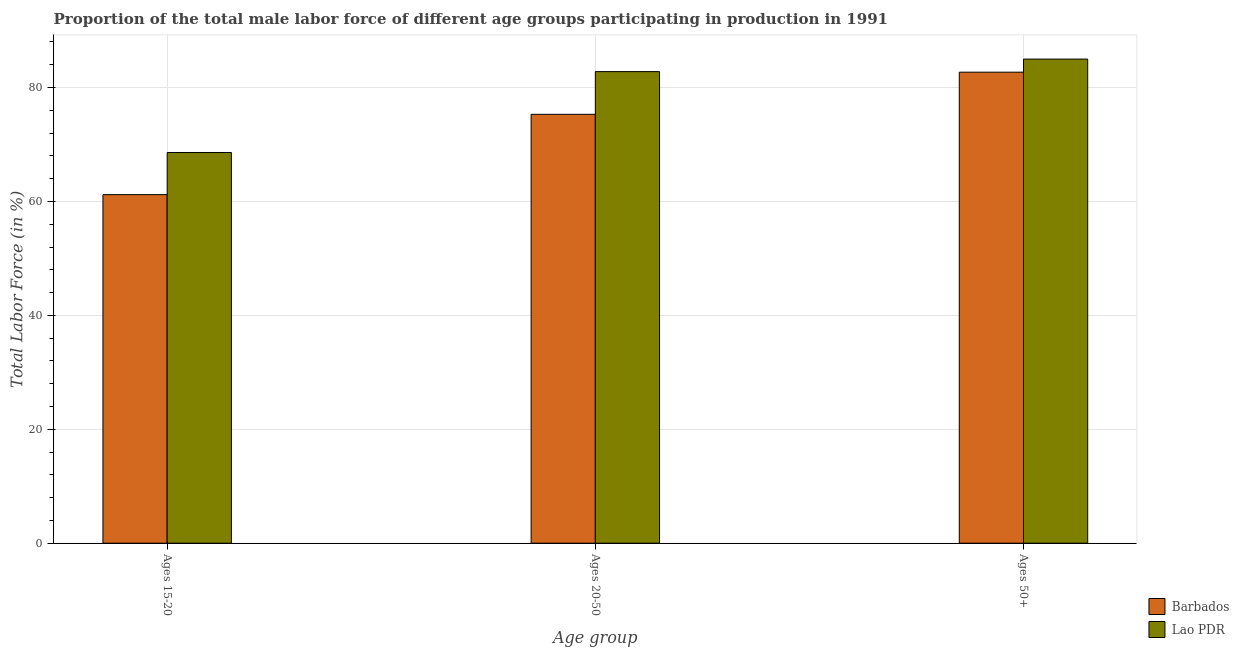How many groups of bars are there?
Your answer should be compact. 3. Are the number of bars on each tick of the X-axis equal?
Offer a very short reply. Yes. How many bars are there on the 2nd tick from the left?
Offer a terse response. 2. How many bars are there on the 3rd tick from the right?
Keep it short and to the point. 2. What is the label of the 2nd group of bars from the left?
Offer a very short reply. Ages 20-50. What is the percentage of male labor force above age 50 in Barbados?
Your answer should be compact. 82.7. Across all countries, what is the minimum percentage of male labor force within the age group 20-50?
Your answer should be very brief. 75.3. In which country was the percentage of male labor force within the age group 20-50 maximum?
Your answer should be very brief. Lao PDR. In which country was the percentage of male labor force above age 50 minimum?
Your response must be concise. Barbados. What is the total percentage of male labor force above age 50 in the graph?
Your response must be concise. 167.7. What is the difference between the percentage of male labor force within the age group 20-50 in Barbados and that in Lao PDR?
Your response must be concise. -7.5. What is the difference between the percentage of male labor force within the age group 20-50 in Lao PDR and the percentage of male labor force above age 50 in Barbados?
Make the answer very short. 0.1. What is the average percentage of male labor force within the age group 20-50 per country?
Offer a very short reply. 79.05. What is the difference between the percentage of male labor force above age 50 and percentage of male labor force within the age group 15-20 in Barbados?
Your answer should be very brief. 21.5. What is the ratio of the percentage of male labor force within the age group 20-50 in Lao PDR to that in Barbados?
Ensure brevity in your answer.  1.1. Is the percentage of male labor force within the age group 20-50 in Lao PDR less than that in Barbados?
Offer a terse response. No. What is the difference between the highest and the second highest percentage of male labor force within the age group 15-20?
Offer a very short reply. 7.4. What does the 2nd bar from the left in Ages 50+ represents?
Provide a succinct answer. Lao PDR. What does the 1st bar from the right in Ages 15-20 represents?
Provide a short and direct response. Lao PDR. How many bars are there?
Keep it short and to the point. 6. How many countries are there in the graph?
Your response must be concise. 2. Does the graph contain any zero values?
Your answer should be very brief. No. How many legend labels are there?
Offer a terse response. 2. What is the title of the graph?
Your answer should be very brief. Proportion of the total male labor force of different age groups participating in production in 1991. What is the label or title of the X-axis?
Keep it short and to the point. Age group. What is the label or title of the Y-axis?
Offer a terse response. Total Labor Force (in %). What is the Total Labor Force (in %) of Barbados in Ages 15-20?
Your answer should be very brief. 61.2. What is the Total Labor Force (in %) in Lao PDR in Ages 15-20?
Offer a very short reply. 68.6. What is the Total Labor Force (in %) of Barbados in Ages 20-50?
Make the answer very short. 75.3. What is the Total Labor Force (in %) in Lao PDR in Ages 20-50?
Give a very brief answer. 82.8. What is the Total Labor Force (in %) in Barbados in Ages 50+?
Keep it short and to the point. 82.7. Across all Age group, what is the maximum Total Labor Force (in %) in Barbados?
Give a very brief answer. 82.7. Across all Age group, what is the maximum Total Labor Force (in %) of Lao PDR?
Keep it short and to the point. 85. Across all Age group, what is the minimum Total Labor Force (in %) of Barbados?
Make the answer very short. 61.2. Across all Age group, what is the minimum Total Labor Force (in %) in Lao PDR?
Keep it short and to the point. 68.6. What is the total Total Labor Force (in %) in Barbados in the graph?
Give a very brief answer. 219.2. What is the total Total Labor Force (in %) in Lao PDR in the graph?
Provide a short and direct response. 236.4. What is the difference between the Total Labor Force (in %) in Barbados in Ages 15-20 and that in Ages 20-50?
Give a very brief answer. -14.1. What is the difference between the Total Labor Force (in %) in Lao PDR in Ages 15-20 and that in Ages 20-50?
Keep it short and to the point. -14.2. What is the difference between the Total Labor Force (in %) in Barbados in Ages 15-20 and that in Ages 50+?
Give a very brief answer. -21.5. What is the difference between the Total Labor Force (in %) in Lao PDR in Ages 15-20 and that in Ages 50+?
Keep it short and to the point. -16.4. What is the difference between the Total Labor Force (in %) of Lao PDR in Ages 20-50 and that in Ages 50+?
Give a very brief answer. -2.2. What is the difference between the Total Labor Force (in %) of Barbados in Ages 15-20 and the Total Labor Force (in %) of Lao PDR in Ages 20-50?
Offer a terse response. -21.6. What is the difference between the Total Labor Force (in %) of Barbados in Ages 15-20 and the Total Labor Force (in %) of Lao PDR in Ages 50+?
Give a very brief answer. -23.8. What is the difference between the Total Labor Force (in %) of Barbados in Ages 20-50 and the Total Labor Force (in %) of Lao PDR in Ages 50+?
Offer a terse response. -9.7. What is the average Total Labor Force (in %) of Barbados per Age group?
Ensure brevity in your answer.  73.07. What is the average Total Labor Force (in %) in Lao PDR per Age group?
Offer a very short reply. 78.8. What is the difference between the Total Labor Force (in %) in Barbados and Total Labor Force (in %) in Lao PDR in Ages 15-20?
Offer a terse response. -7.4. What is the ratio of the Total Labor Force (in %) in Barbados in Ages 15-20 to that in Ages 20-50?
Keep it short and to the point. 0.81. What is the ratio of the Total Labor Force (in %) in Lao PDR in Ages 15-20 to that in Ages 20-50?
Keep it short and to the point. 0.83. What is the ratio of the Total Labor Force (in %) in Barbados in Ages 15-20 to that in Ages 50+?
Your response must be concise. 0.74. What is the ratio of the Total Labor Force (in %) of Lao PDR in Ages 15-20 to that in Ages 50+?
Ensure brevity in your answer.  0.81. What is the ratio of the Total Labor Force (in %) of Barbados in Ages 20-50 to that in Ages 50+?
Ensure brevity in your answer.  0.91. What is the ratio of the Total Labor Force (in %) of Lao PDR in Ages 20-50 to that in Ages 50+?
Offer a terse response. 0.97. What is the difference between the highest and the second highest Total Labor Force (in %) in Barbados?
Offer a terse response. 7.4. What is the difference between the highest and the second highest Total Labor Force (in %) of Lao PDR?
Offer a terse response. 2.2. What is the difference between the highest and the lowest Total Labor Force (in %) in Barbados?
Keep it short and to the point. 21.5. 